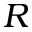Convert formula to latex. <formula><loc_0><loc_0><loc_500><loc_500>R</formula> 